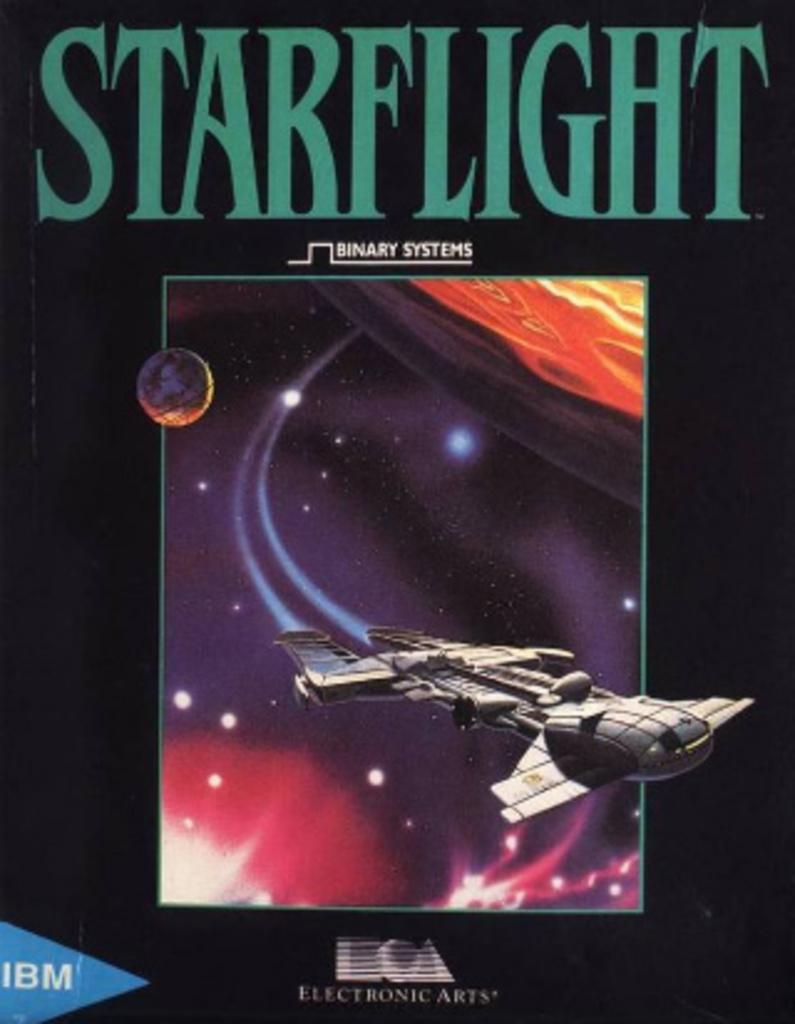Describe this image in one or two sentences. In this image we can see a poster, on the poster we can see some text and an image. 